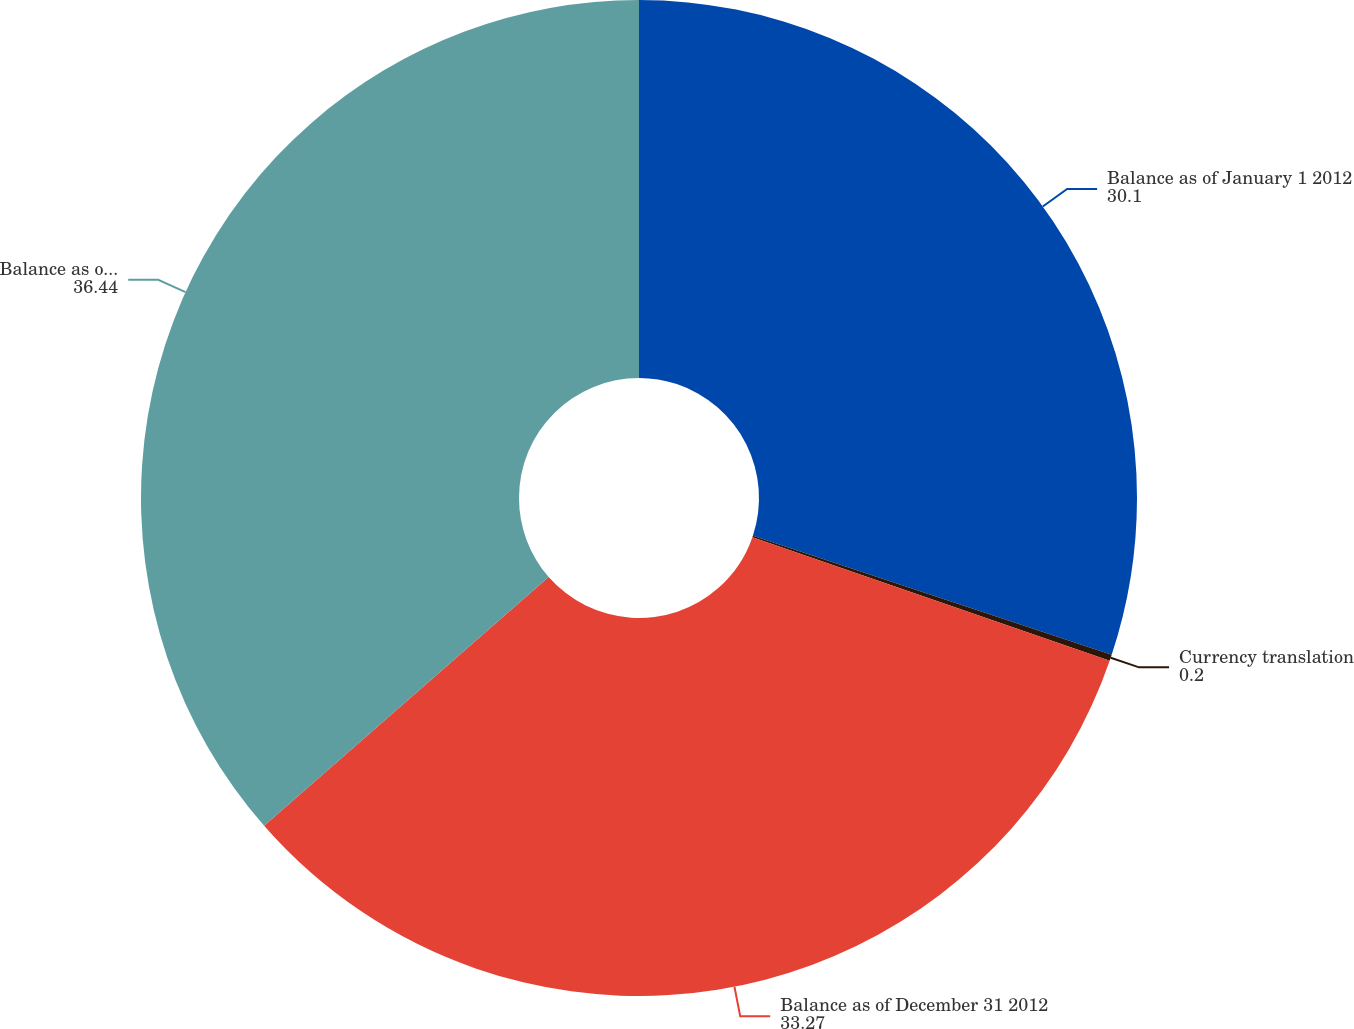<chart> <loc_0><loc_0><loc_500><loc_500><pie_chart><fcel>Balance as of January 1 2012<fcel>Currency translation<fcel>Balance as of December 31 2012<fcel>Balance as of December 31 2013<nl><fcel>30.1%<fcel>0.2%<fcel>33.27%<fcel>36.44%<nl></chart> 